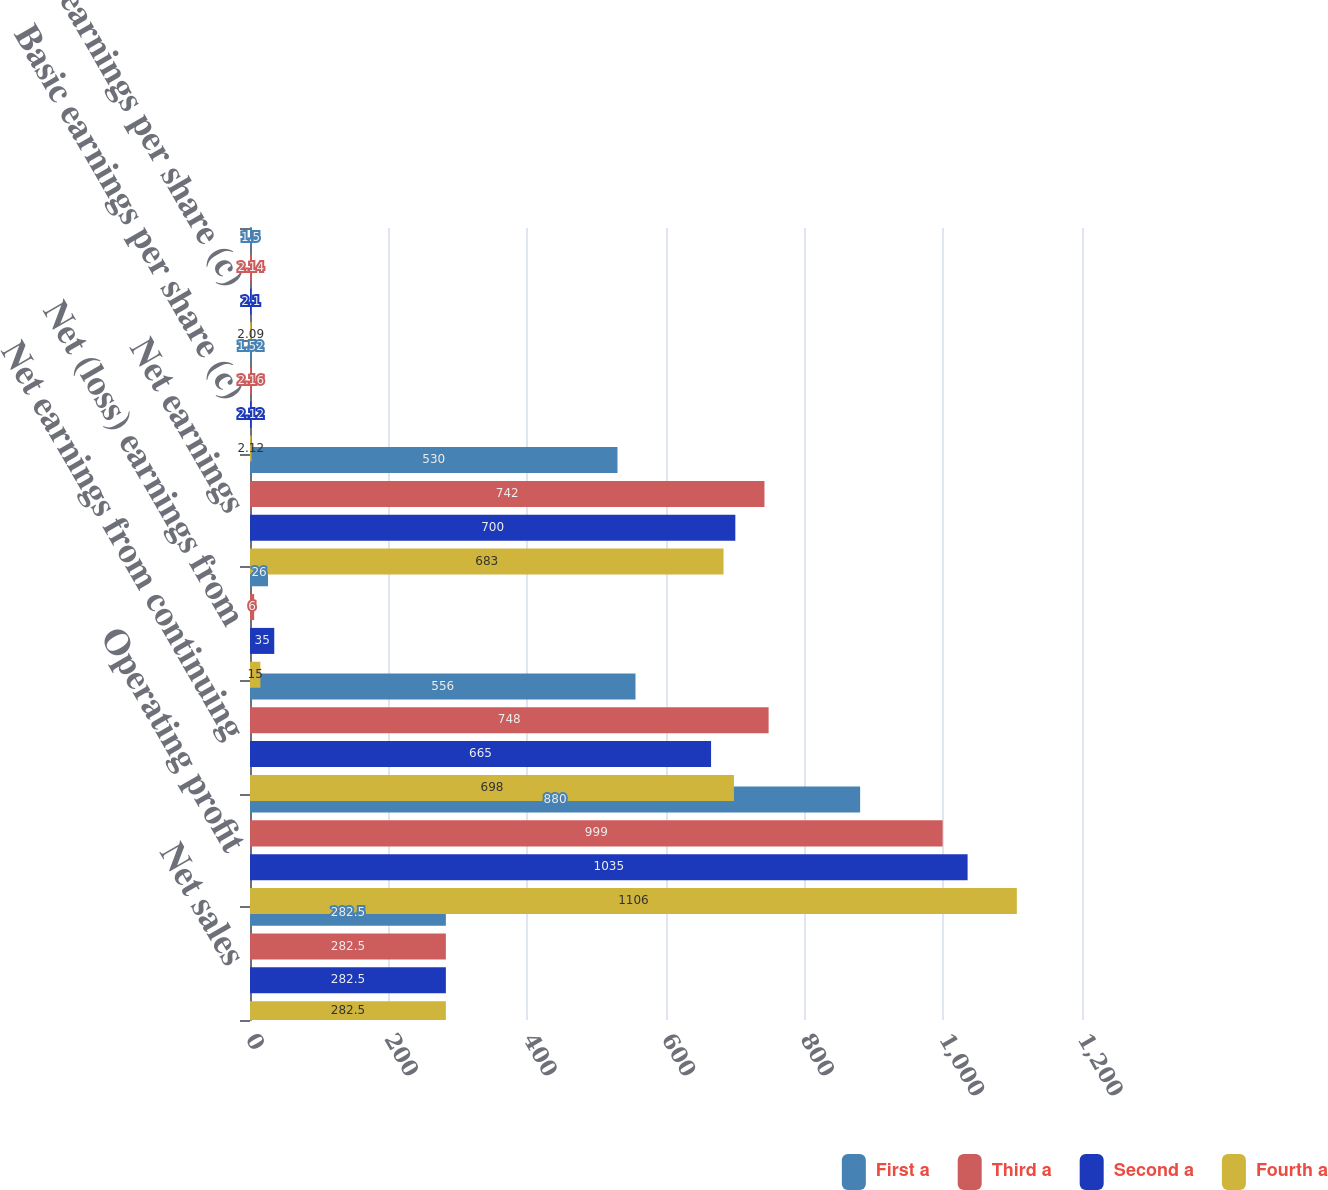Convert chart to OTSL. <chart><loc_0><loc_0><loc_500><loc_500><stacked_bar_chart><ecel><fcel>Net sales<fcel>Operating profit<fcel>Net earnings from continuing<fcel>Net (loss) earnings from<fcel>Net earnings<fcel>Basic earnings per share (c)<fcel>Diluted earnings per share (c)<nl><fcel>First a<fcel>282.5<fcel>880<fcel>556<fcel>26<fcel>530<fcel>1.52<fcel>1.5<nl><fcel>Third a<fcel>282.5<fcel>999<fcel>748<fcel>6<fcel>742<fcel>2.16<fcel>2.14<nl><fcel>Second a<fcel>282.5<fcel>1035<fcel>665<fcel>35<fcel>700<fcel>2.12<fcel>2.1<nl><fcel>Fourth a<fcel>282.5<fcel>1106<fcel>698<fcel>15<fcel>683<fcel>2.12<fcel>2.09<nl></chart> 